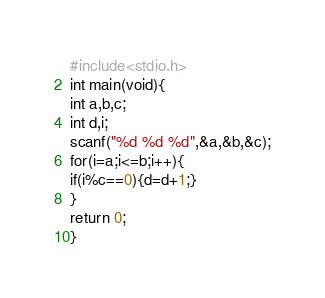<code> <loc_0><loc_0><loc_500><loc_500><_C_>#include<stdio.h>
int main(void){
int a,b,c;
int d,i;
scanf("%d %d %d",&a,&b,&c);
for(i=a;i<=b;i++){
if(i%c==0){d=d+1;}
}
return 0;
}</code> 